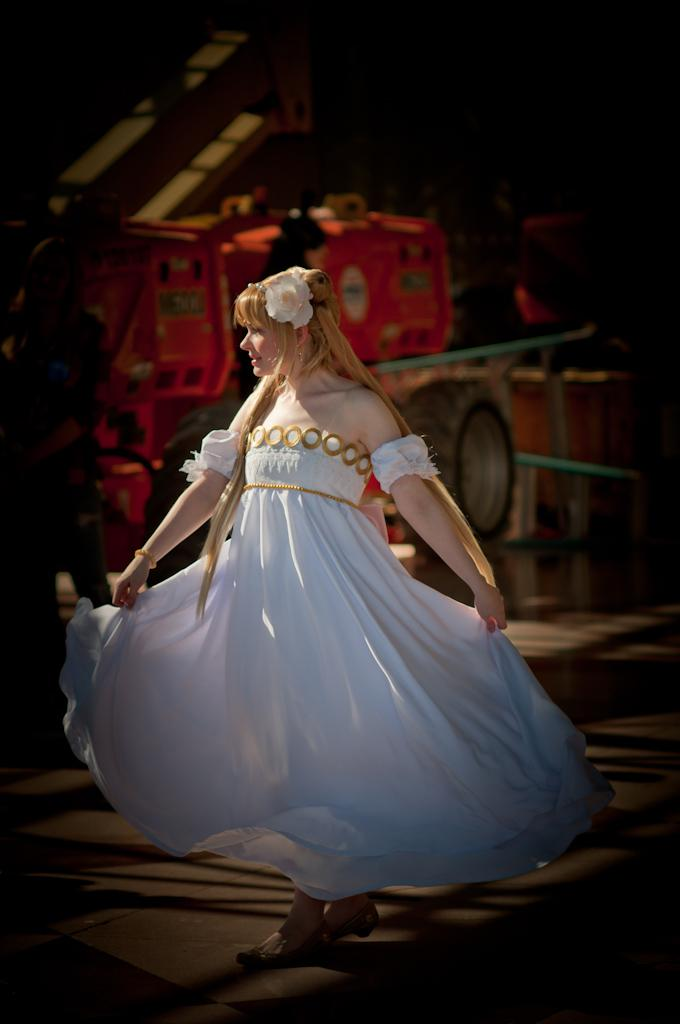Who is the main subject in the image? There is a lady in the center of the image. What is the lady wearing? The lady is wearing a white dress. What can be seen in the background of the image? There is a vehicle in the background of the image. What is at the bottom of the image? There is a road at the bottom of the image. What type of cabbage is being harvested by the creature in the image? There is no creature or cabbage present in the image. How does the lady say good-bye to the people in the image? The image does not show the lady interacting with people or saying good-bye. 